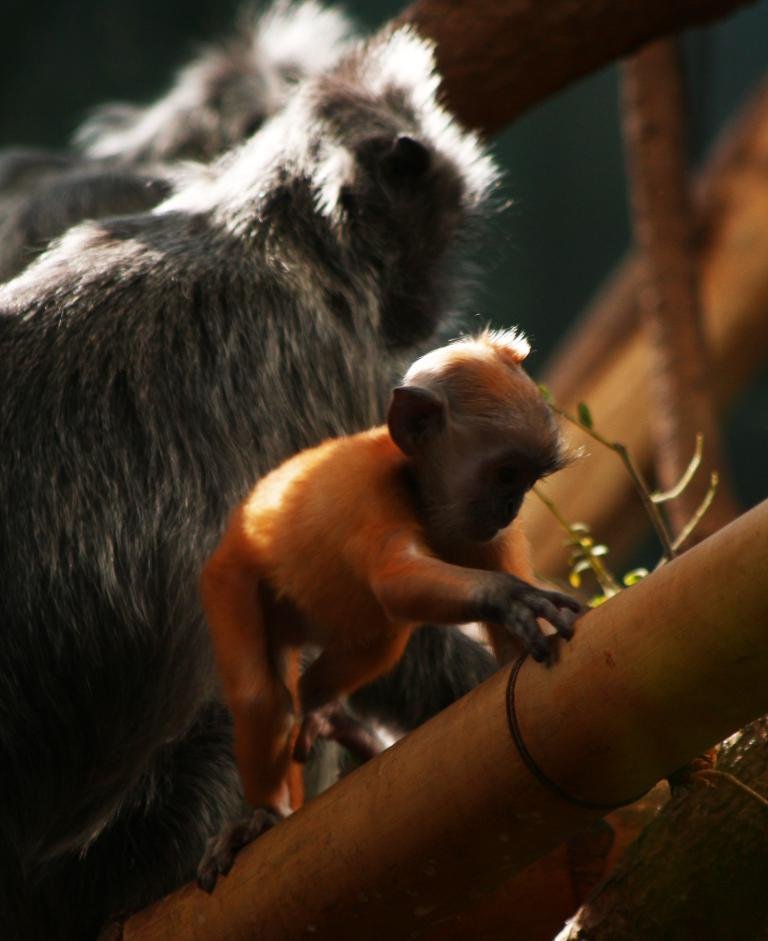What animals are present in the image? There are monkeys in the image. What is one of the monkeys holding? One of the monkeys is holding a bamboo stick. How many mice are visible in the image? There are no mice present in the image; it features monkeys. What type of peace symbol can be seen in the image? There is no peace symbol present in the image. 